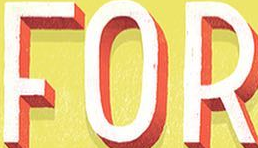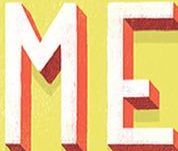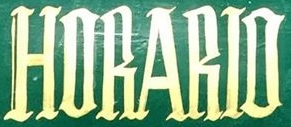What words are shown in these images in order, separated by a semicolon? FOR; ME; HORARIO 